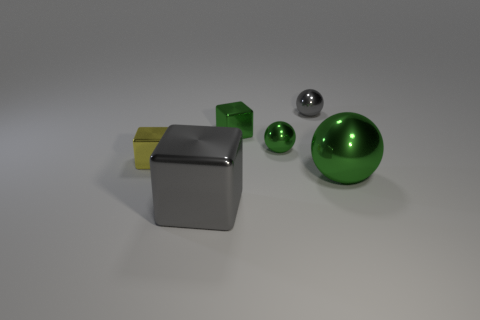What is the material of the other green object that is the same shape as the large green metal object?
Provide a succinct answer. Metal. Does the tiny green cube have the same material as the tiny green sphere?
Keep it short and to the point. Yes. The large metal thing on the left side of the big green ball has what shape?
Offer a very short reply. Cube. There is a thing that is in front of the large green shiny ball; are there any tiny yellow metal cubes behind it?
Your answer should be very brief. Yes. Are there any yellow metal blocks that have the same size as the green metal block?
Give a very brief answer. Yes. There is a small metallic sphere in front of the small green block; is it the same color as the large sphere?
Your response must be concise. Yes. The gray ball has what size?
Make the answer very short. Small. There is a green ball right of the small shiny ball in front of the gray ball; how big is it?
Provide a short and direct response. Large. How many shiny things are the same color as the big cube?
Provide a short and direct response. 1. How many tiny green things are there?
Keep it short and to the point. 2. 